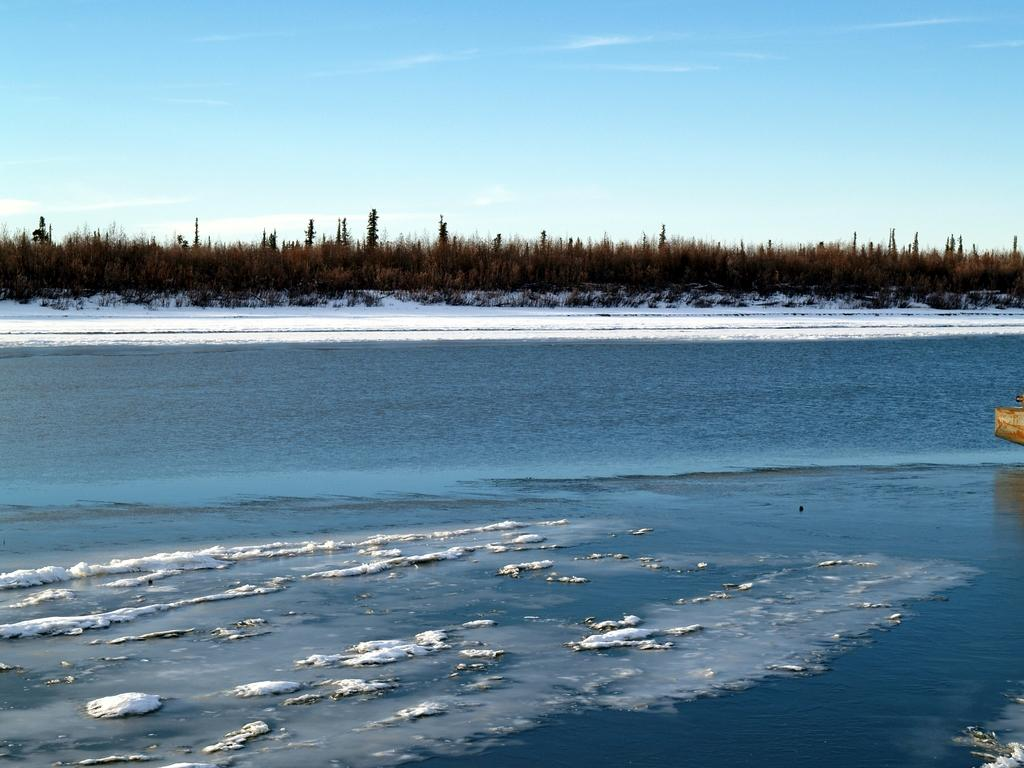What is visible in the image? Water is visible in the image. What can be seen in the background of the image? There are trees and snow in the background of the image. What else is visible in the background of the image? The sky is visible in the background of the image. Where are the hands of the spiders in the image? There are no spiders or hands present in the image. 